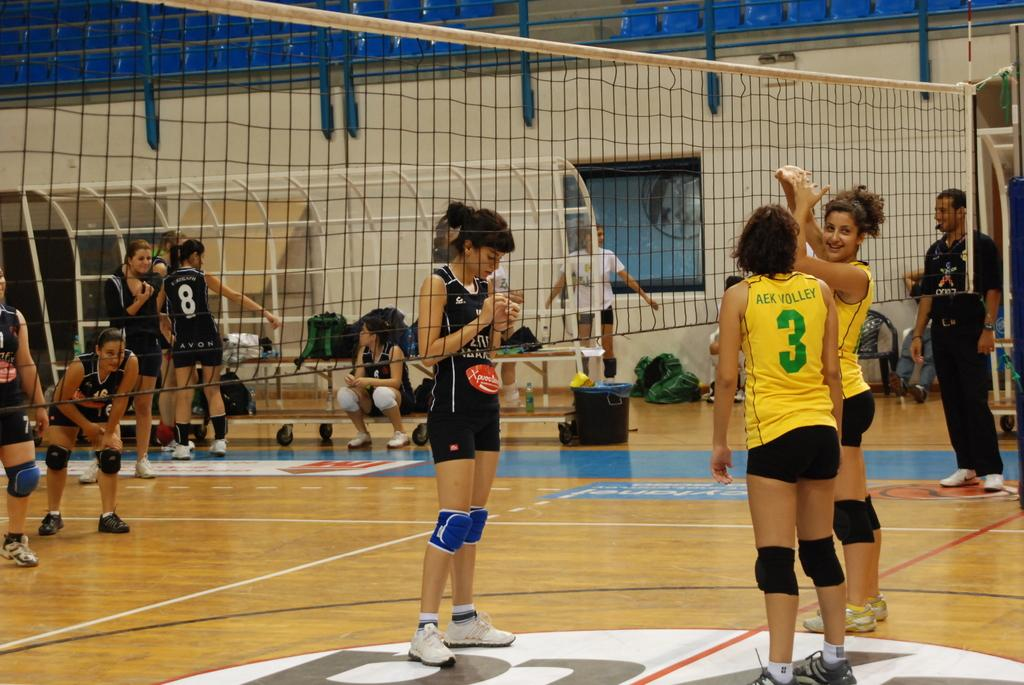<image>
Summarize the visual content of the image. Volleyball player number 3 on the yellow team is talking to another player while the players stand around getting ready to play. 